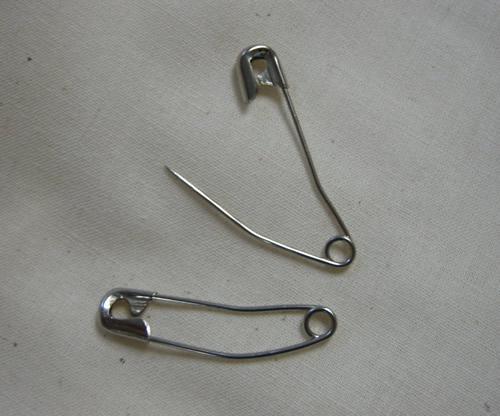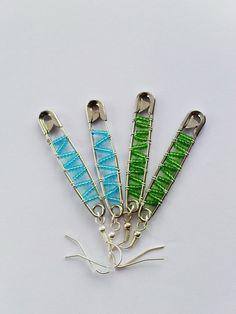The first image is the image on the left, the second image is the image on the right. For the images shown, is this caption "The left image contains exactly two unadorned, separate safety pins, and the right image contains exactly four safety pins." true? Answer yes or no. Yes. 